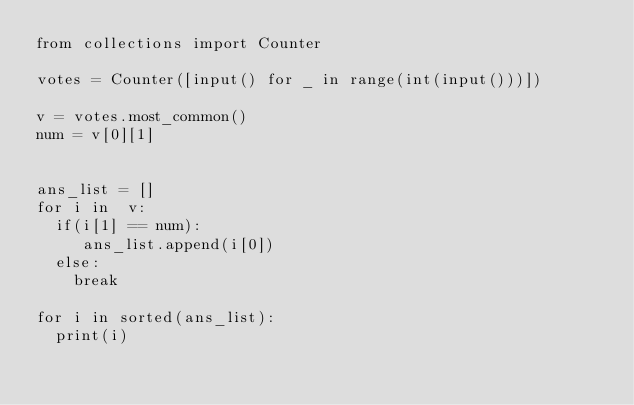<code> <loc_0><loc_0><loc_500><loc_500><_Python_>from collections import Counter

votes = Counter([input() for _ in range(int(input()))])

v = votes.most_common()
num = v[0][1]


ans_list = []
for i in  v:
	if(i[1] == num):
		 ans_list.append(i[0])
	else:
		break

for i in sorted(ans_list):
	print(i)


	
</code> 